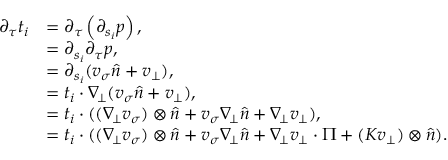<formula> <loc_0><loc_0><loc_500><loc_500>\begin{array} { r l } { \partial _ { \tau } t _ { i } } & { = \partial _ { \tau } \left ( \partial _ { s _ { i } } p \right ) , } \\ & { = \partial _ { s _ { i } } \partial _ { \tau } p , } \\ & { = \partial _ { s _ { i } } ( v _ { \sigma } \widehat { n } + v _ { \bot } ) , } \\ & { = t _ { i } \cdot \nabla _ { \, \bot } ( v _ { \sigma } \widehat { n } + v _ { \bot } ) , } \\ & { = t _ { i } \cdot ( ( \nabla _ { \, \bot } v _ { \sigma } ) \otimes \widehat { n } + v _ { \sigma } \nabla _ { \, \bot } \widehat { n } + \nabla _ { \, \bot } v _ { \bot } ) , } \\ & { = t _ { i } \cdot ( ( \nabla _ { \, \bot } v _ { \sigma } ) \otimes \widehat { n } + v _ { \sigma } \nabla _ { \, \bot } \widehat { n } + \nabla _ { \, \bot } v _ { \bot } \cdot \Pi + ( K v _ { \bot } ) \otimes \widehat { n } ) . } \end{array}</formula> 